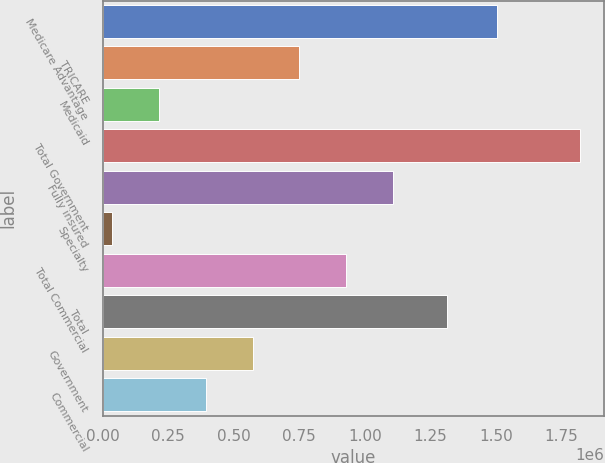Convert chart to OTSL. <chart><loc_0><loc_0><loc_500><loc_500><bar_chart><fcel>Medicare Advantage<fcel>TRICARE<fcel>Medicaid<fcel>Total Government<fcel>Fully insured<fcel>Specialty<fcel>Total Commercial<fcel>Total<fcel>Government<fcel>Commercial<nl><fcel>1.50376e+06<fcel>750847<fcel>215599<fcel>1.82134e+06<fcel>1.10768e+06<fcel>37183<fcel>929263<fcel>1.31216e+06<fcel>572431<fcel>394015<nl></chart> 